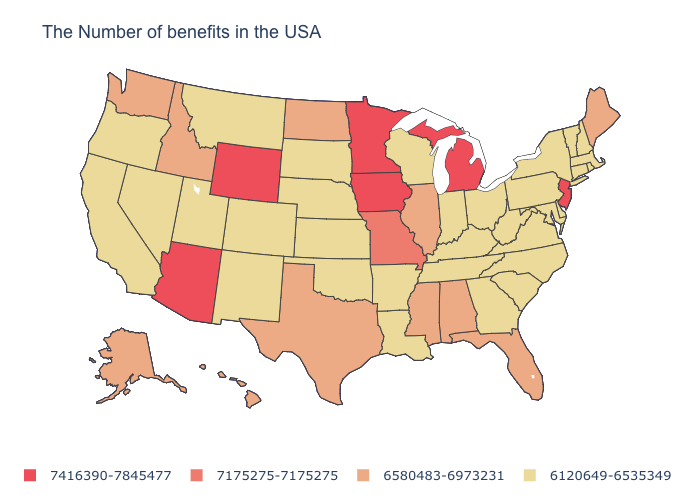What is the highest value in states that border Nevada?
Quick response, please. 7416390-7845477. Name the states that have a value in the range 6120649-6535349?
Answer briefly. Massachusetts, Rhode Island, New Hampshire, Vermont, Connecticut, New York, Delaware, Maryland, Pennsylvania, Virginia, North Carolina, South Carolina, West Virginia, Ohio, Georgia, Kentucky, Indiana, Tennessee, Wisconsin, Louisiana, Arkansas, Kansas, Nebraska, Oklahoma, South Dakota, Colorado, New Mexico, Utah, Montana, Nevada, California, Oregon. How many symbols are there in the legend?
Keep it brief. 4. Among the states that border Washington , does Idaho have the lowest value?
Quick response, please. No. How many symbols are there in the legend?
Keep it brief. 4. What is the highest value in the USA?
Short answer required. 7416390-7845477. Which states have the lowest value in the USA?
Short answer required. Massachusetts, Rhode Island, New Hampshire, Vermont, Connecticut, New York, Delaware, Maryland, Pennsylvania, Virginia, North Carolina, South Carolina, West Virginia, Ohio, Georgia, Kentucky, Indiana, Tennessee, Wisconsin, Louisiana, Arkansas, Kansas, Nebraska, Oklahoma, South Dakota, Colorado, New Mexico, Utah, Montana, Nevada, California, Oregon. What is the lowest value in states that border Florida?
Write a very short answer. 6120649-6535349. Among the states that border Mississippi , does Alabama have the lowest value?
Give a very brief answer. No. Does Iowa have the highest value in the USA?
Keep it brief. Yes. What is the lowest value in the West?
Quick response, please. 6120649-6535349. What is the value of New Mexico?
Keep it brief. 6120649-6535349. What is the value of Ohio?
Be succinct. 6120649-6535349. What is the value of Alaska?
Answer briefly. 6580483-6973231. 